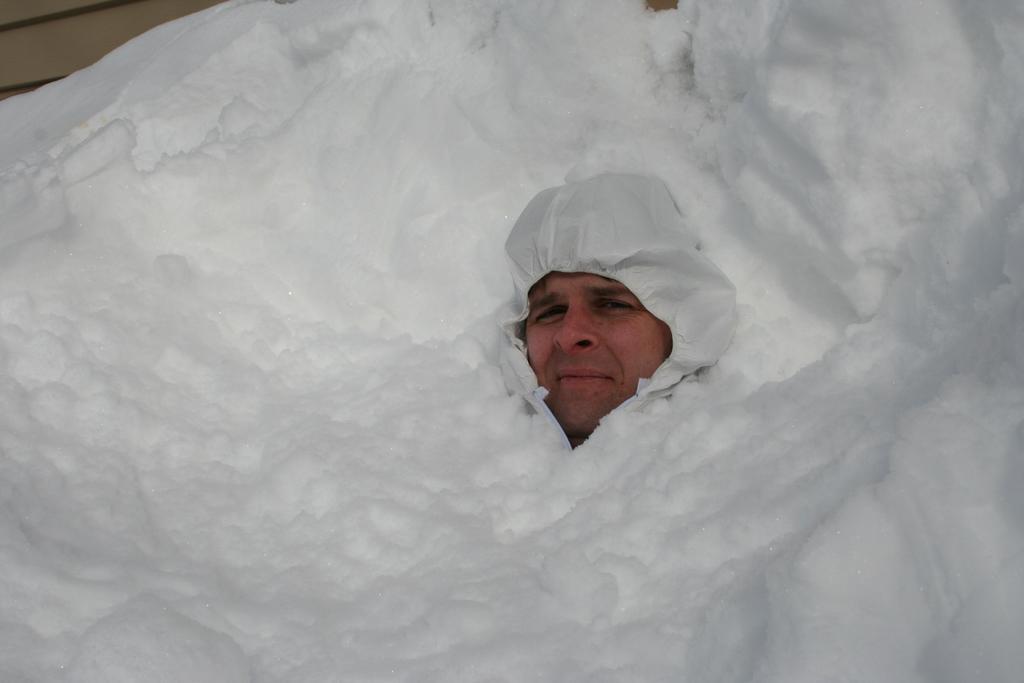In one or two sentences, can you explain what this image depicts? This image consists of a man. It looks like he is in the snow. And wearing a white cap. 